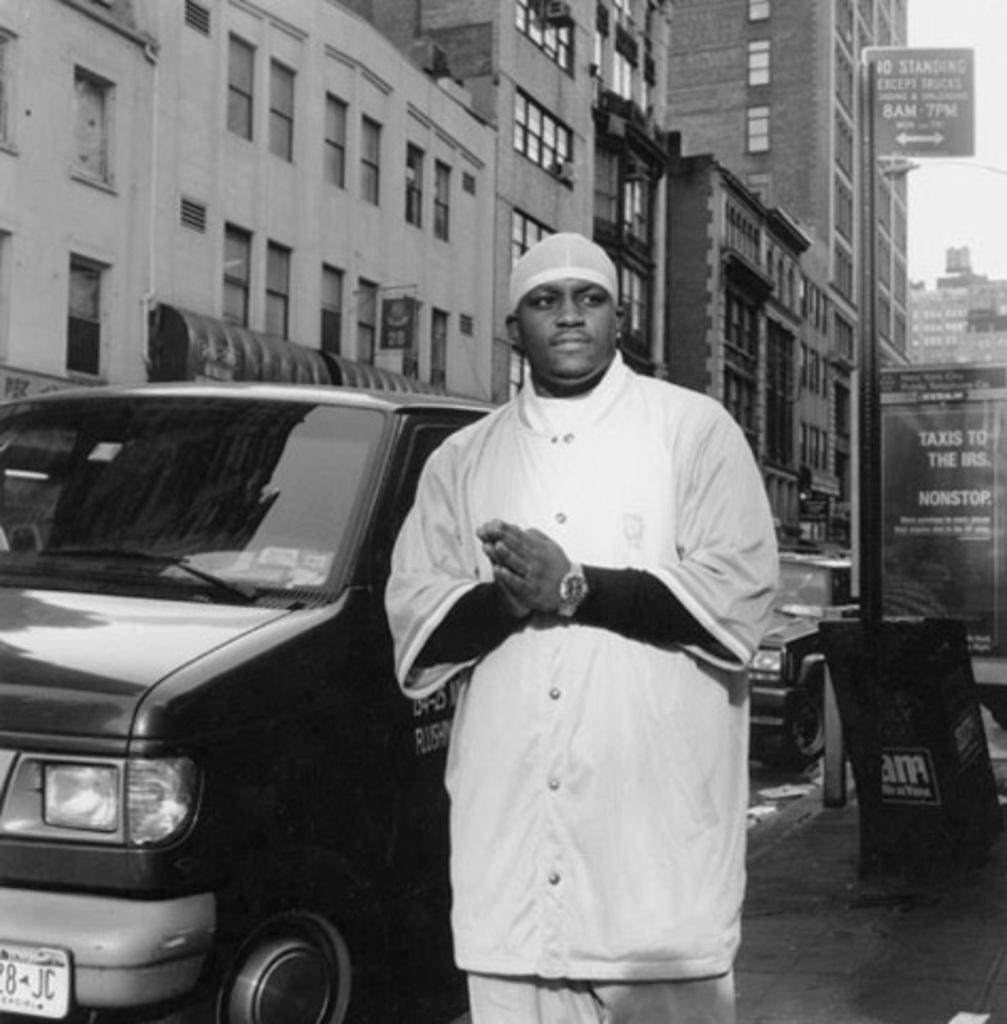Provide a one-sentence caption for the provided image. black & white photo of a man in black next to a van and a sign that has taxis to the irs on it in the background. 